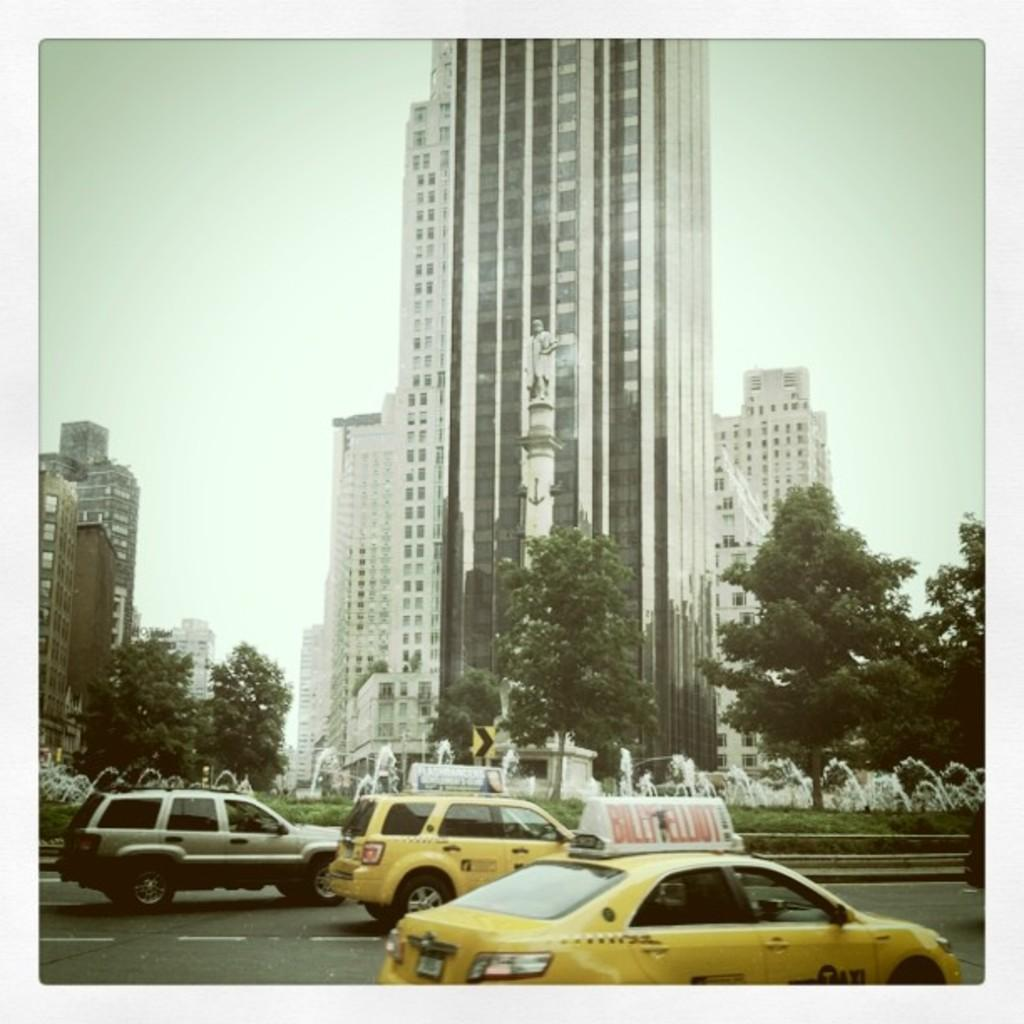<image>
Offer a succinct explanation of the picture presented. a car that has the name Billy Elliot at the top 